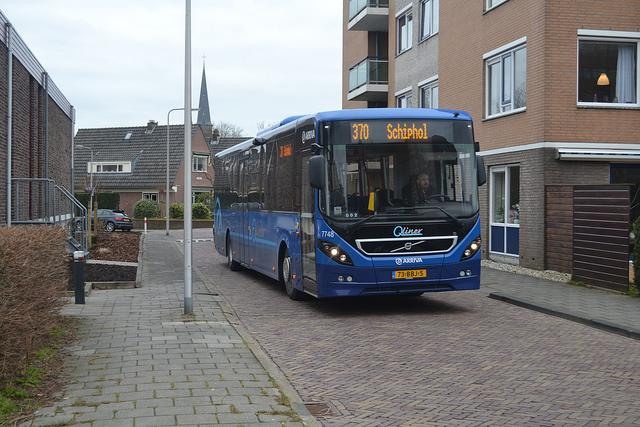What kind of problem is likely to be experienced by the apartment residents? Please explain your reasoning. noise. All the answers listed here could be viable, but most likely in an over-populated area is noisy. 